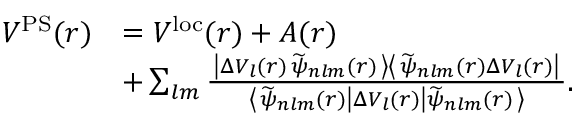Convert formula to latex. <formula><loc_0><loc_0><loc_500><loc_500>\begin{array} { r l } { V ^ { P S } ( r ) } & { = V ^ { l o c } ( r ) + A ( r ) } \\ & { + \sum _ { l m } \frac { \left | \Delta V _ { l } ( r ) \, \widetilde { \psi } _ { n l m } ( r ) \right > \left < \widetilde { \psi } _ { n l m } ( r ) \Delta V _ { l } ( r ) \right | } { \left < \widetilde { \psi } _ { n l m } ( r ) \right | \Delta V _ { l } ( r ) \left | \widetilde { \psi } _ { n l m } ( r ) \right > } . } \end{array}</formula> 